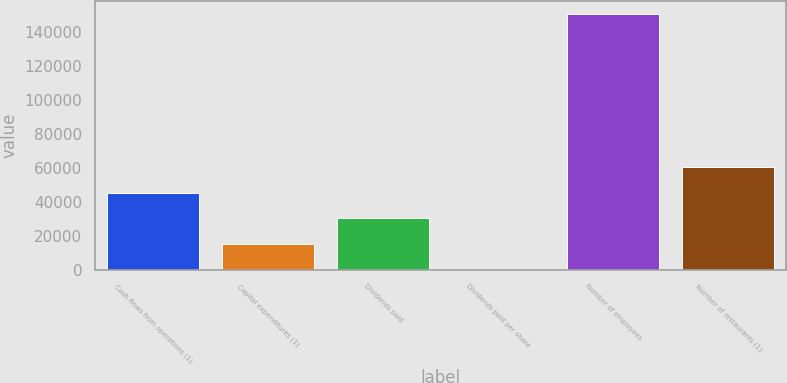Convert chart. <chart><loc_0><loc_0><loc_500><loc_500><bar_chart><fcel>Cash flows from operations (1)<fcel>Capital expenditures (1)<fcel>Dividends paid<fcel>Dividends paid per share<fcel>Number of employees<fcel>Number of restaurants (1)<nl><fcel>45284.1<fcel>15096.1<fcel>30190.1<fcel>2.1<fcel>150942<fcel>60378.1<nl></chart> 